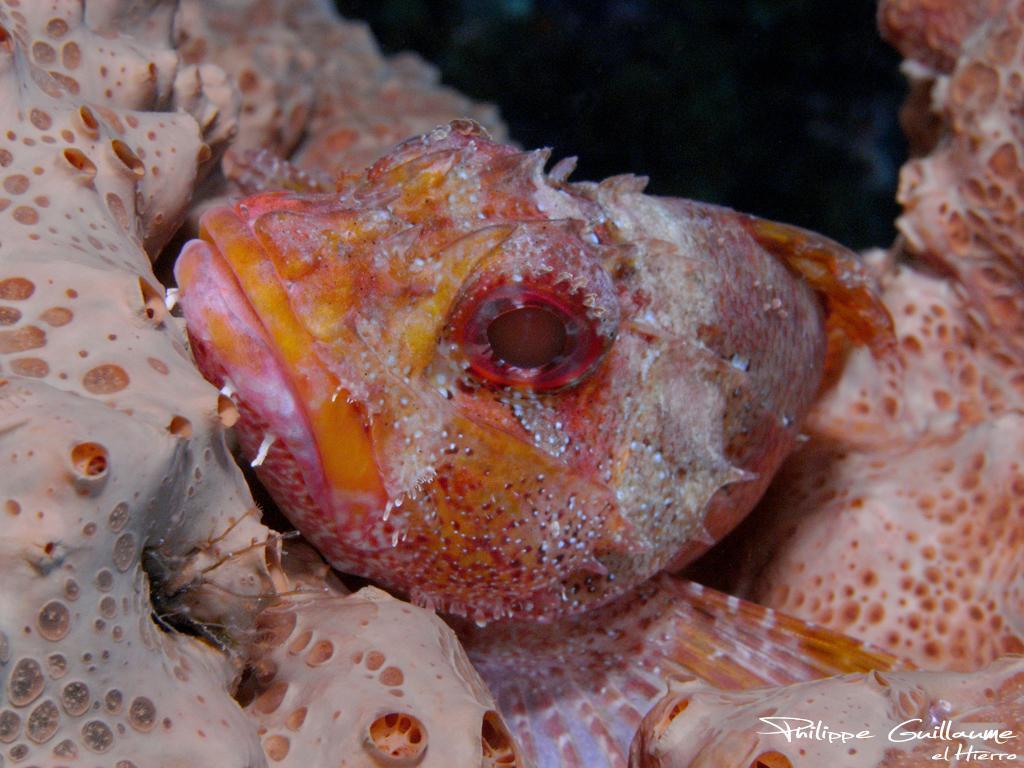Could you give a brief overview of what you see in this image? This image consists of fishes. In the front, we can see a fish in orange color. 